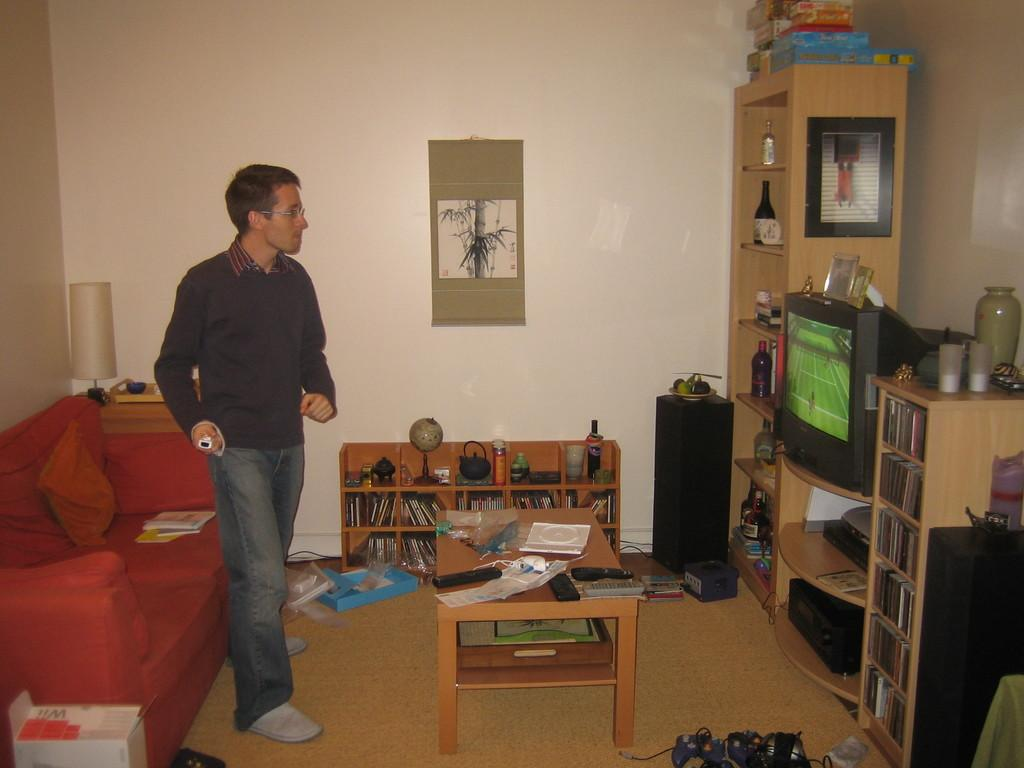What piece of furniture is located on the left side of the image? There is a sofa on the left side of the image. Who is present near the sofa in the image? A man is standing near the sofa. What can be seen on the right side of the image? There is a TV on the right side of the image. What separates the sofa and the TV in the image? There is a wall in the middle of the image. What type of riddle is being solved in the image? There is no riddle present in the image. What is the aftermath of the event depicted in the image? There is no event or aftermath depicted in the image; it shows a man standing near a sofa, a TV, and a wall. 